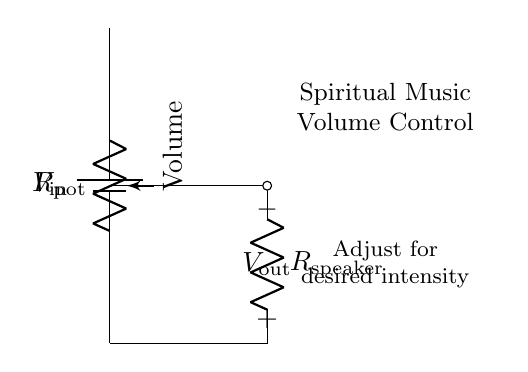What is the input voltage of the circuit? The input voltage is labeled as V_in at the top of the circuit. It represents the source voltage supplied to the circuit.
Answer: V_in What type of component is used to adjust the volume? The volume is adjusted using a potentiometer, which is shown in the circuit diagram as a variable resistor. This allows for changing resistance to control the output voltage.
Answer: Potentiometer What is the purpose of R_speaker in this circuit? R_speaker acts as the load in this circuit. It presents a resistance that the output voltage is driving, relating to the intensity of the sound output.
Answer: Load How many connections are made to the potentiometer? The potentiometer has three connections: one for input voltage, one for output voltage, and one for ground. These facilitate the variable adjustment of the voltage across the speaker.
Answer: Three If the resistance of R_pot is increased, what happens to V_out? Increasing R_pot will result in a higher output voltage (V_out) across R_speaker, causing the volume of the music to increase. This is due to the changes in the voltage divider ratio determined by the resistances.
Answer: It increases What relationship defines the output voltage in this circuit? The output voltage (V_out) is defined by the voltage division rule, which states V_out = (R_speaker / (R_pot + R_speaker)) * V_in, indicating how the total voltage is divided between the resistances.
Answer: Voltage division rule At what point in the circuit is V_out measured? V_out is measured at the junction between the potentiometer and R_speaker, indicating the voltage that can vary depending on the adjustment of the potentiometer.
Answer: At the junction of potentiometer and R_speaker 